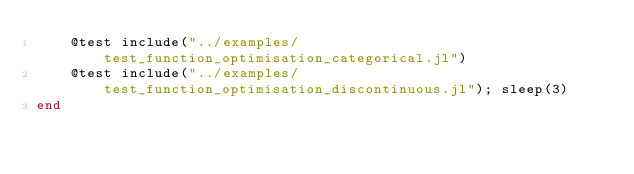<code> <loc_0><loc_0><loc_500><loc_500><_Julia_>    @test include("../examples/test_function_optimisation_categorical.jl")
    @test include("../examples/test_function_optimisation_discontinuous.jl"); sleep(3)
end</code> 